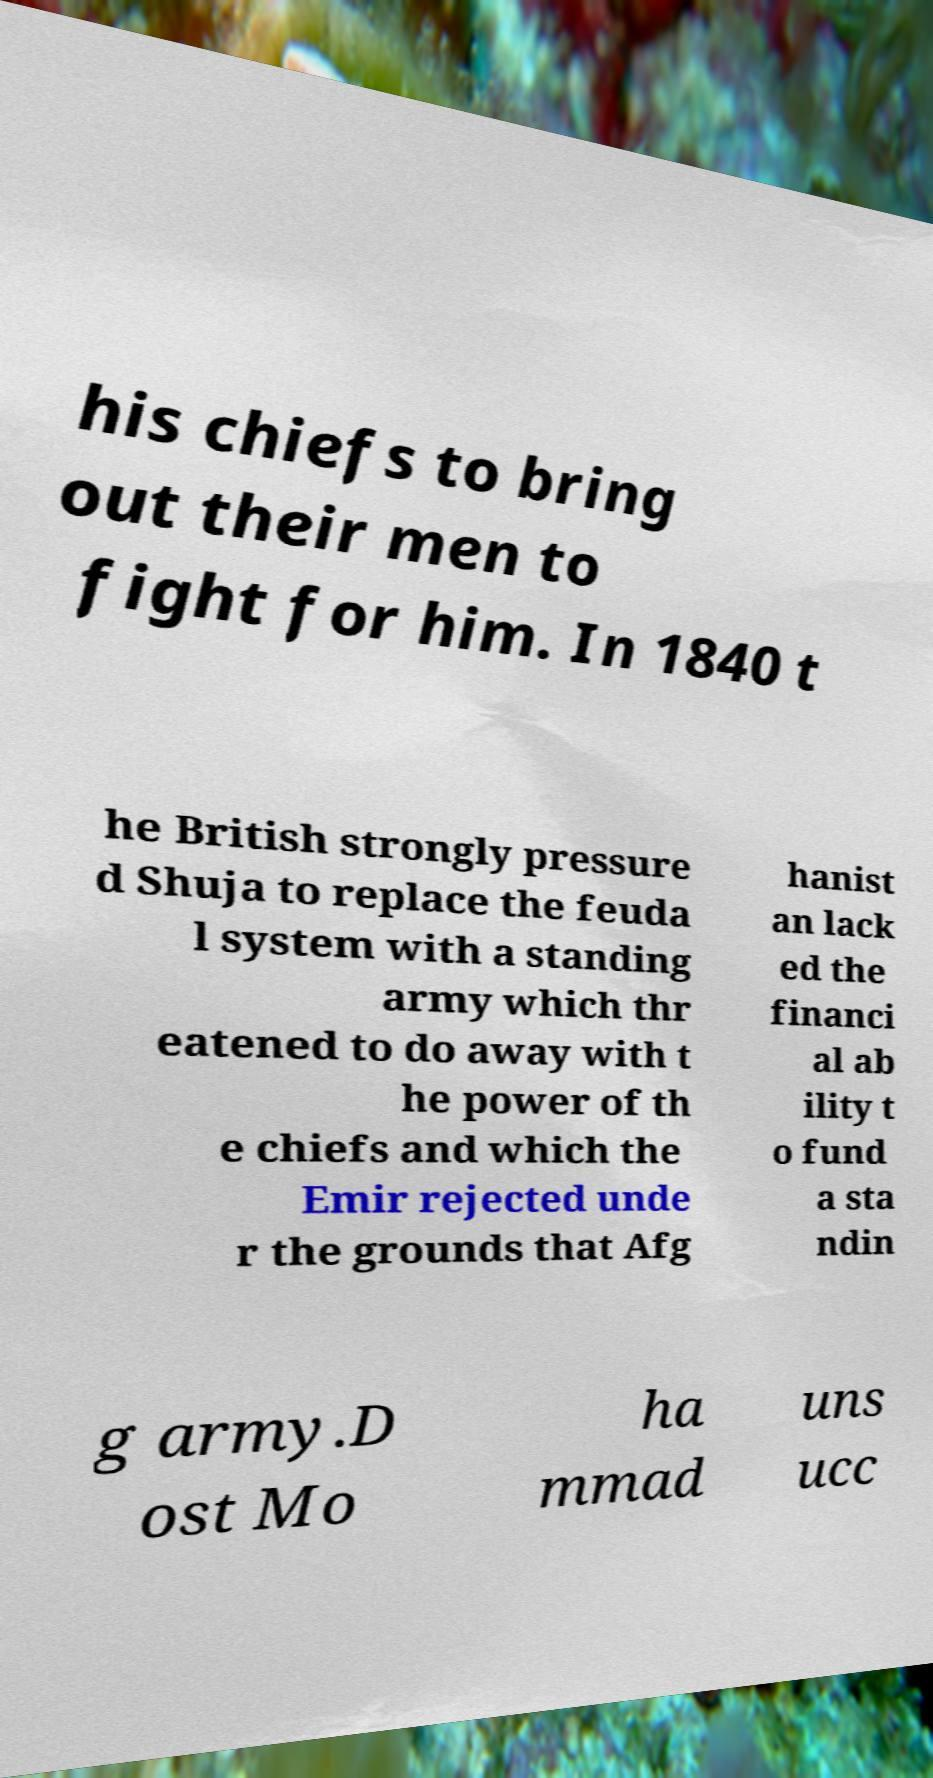I need the written content from this picture converted into text. Can you do that? his chiefs to bring out their men to fight for him. In 1840 t he British strongly pressure d Shuja to replace the feuda l system with a standing army which thr eatened to do away with t he power of th e chiefs and which the Emir rejected unde r the grounds that Afg hanist an lack ed the financi al ab ility t o fund a sta ndin g army.D ost Mo ha mmad uns ucc 